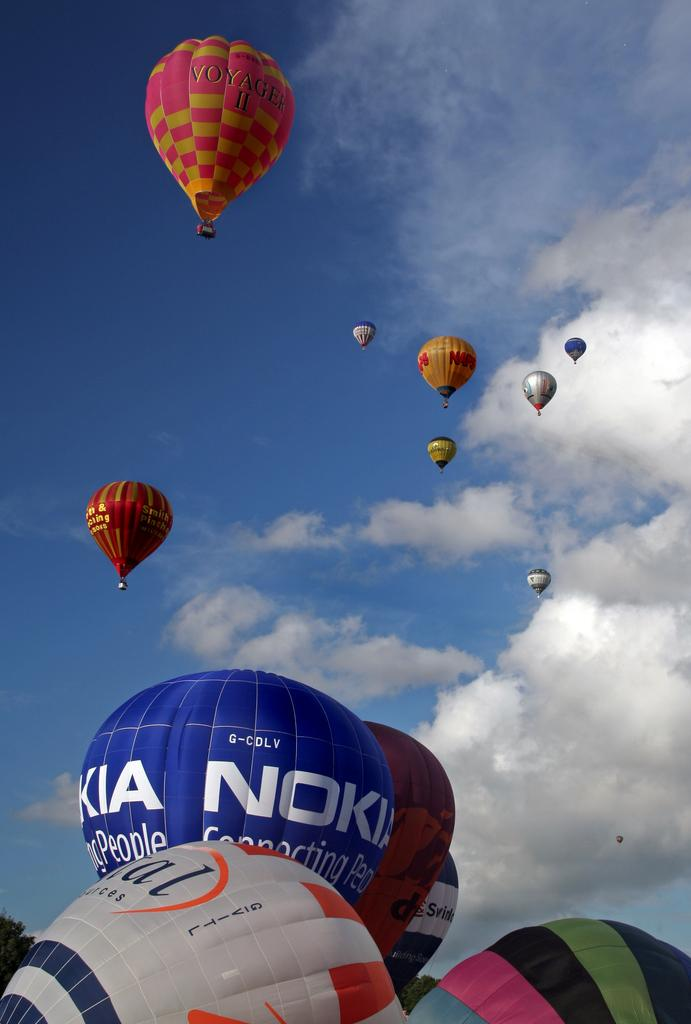Provide a one-sentence caption for the provided image. colorful hot air balloons include ones by Voyager II and Nokia. 